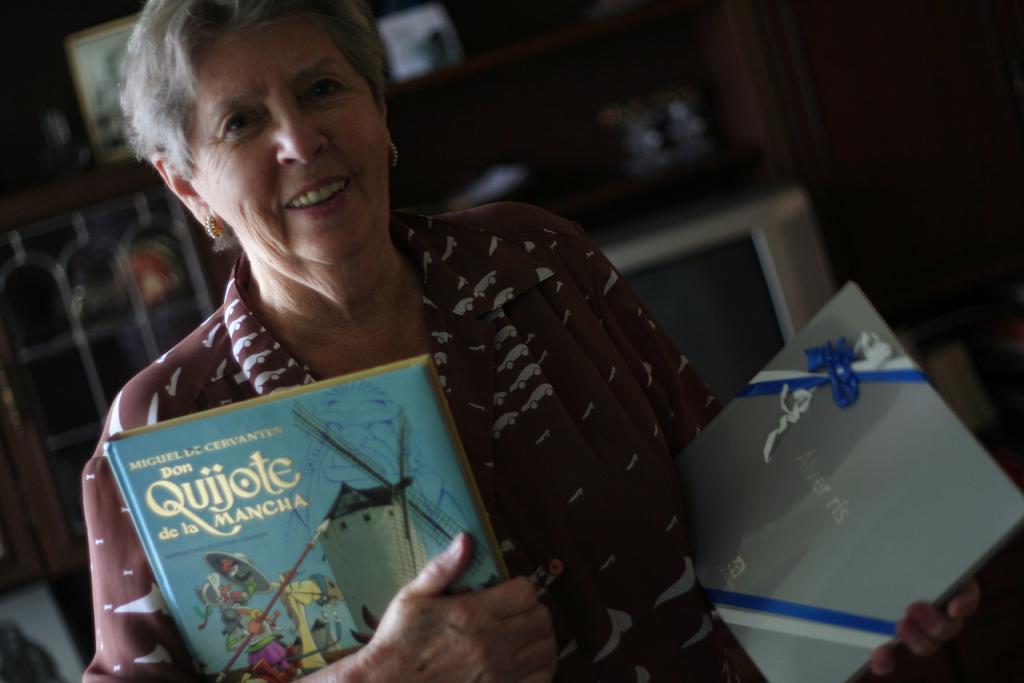Please provide a concise description of this image. As we can see in the image in the front there is a woman holding books and the image is little dark. 